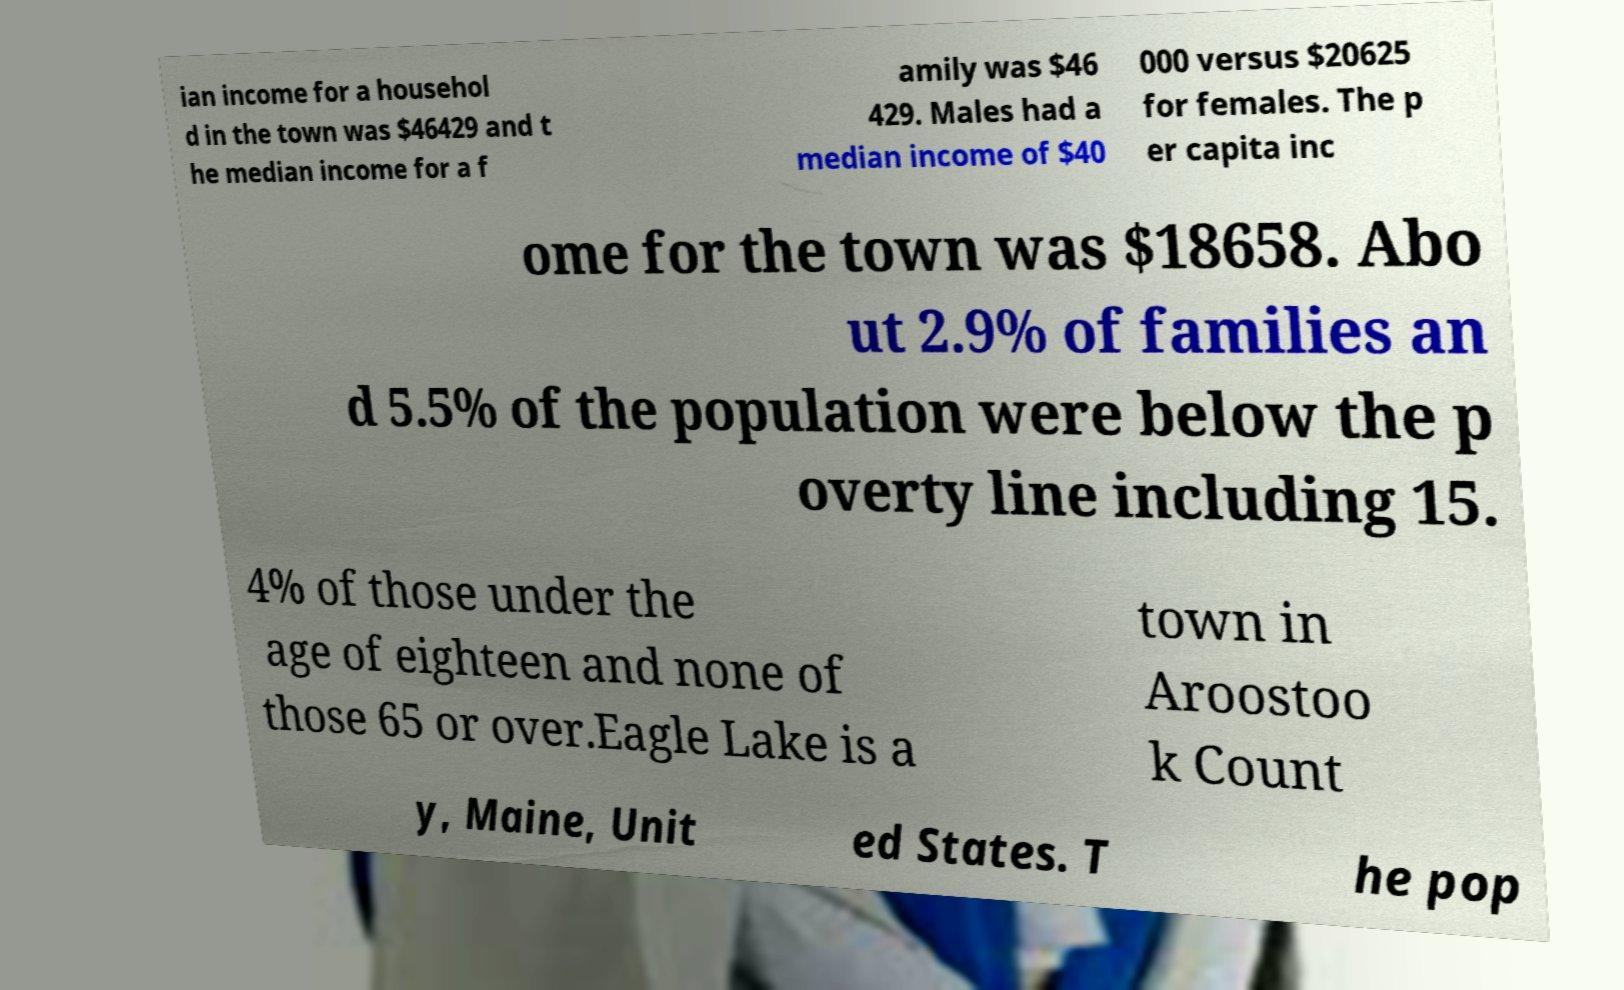Could you assist in decoding the text presented in this image and type it out clearly? ian income for a househol d in the town was $46429 and t he median income for a f amily was $46 429. Males had a median income of $40 000 versus $20625 for females. The p er capita inc ome for the town was $18658. Abo ut 2.9% of families an d 5.5% of the population were below the p overty line including 15. 4% of those under the age of eighteen and none of those 65 or over.Eagle Lake is a town in Aroostoo k Count y, Maine, Unit ed States. T he pop 